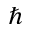<formula> <loc_0><loc_0><loc_500><loc_500>\hbar</formula> 